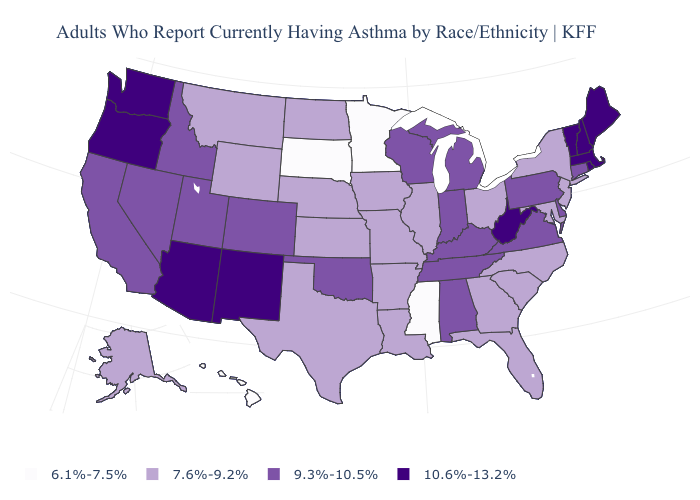Name the states that have a value in the range 7.6%-9.2%?
Write a very short answer. Alaska, Arkansas, Florida, Georgia, Illinois, Iowa, Kansas, Louisiana, Maryland, Missouri, Montana, Nebraska, New Jersey, New York, North Carolina, North Dakota, Ohio, South Carolina, Texas, Wyoming. How many symbols are there in the legend?
Quick response, please. 4. Among the states that border Arkansas , does Mississippi have the lowest value?
Concise answer only. Yes. Name the states that have a value in the range 9.3%-10.5%?
Write a very short answer. Alabama, California, Colorado, Connecticut, Delaware, Idaho, Indiana, Kentucky, Michigan, Nevada, Oklahoma, Pennsylvania, Tennessee, Utah, Virginia, Wisconsin. Does Maine have the highest value in the USA?
Keep it brief. Yes. Which states have the lowest value in the Northeast?
Concise answer only. New Jersey, New York. What is the lowest value in the USA?
Short answer required. 6.1%-7.5%. How many symbols are there in the legend?
Answer briefly. 4. Which states have the lowest value in the USA?
Keep it brief. Hawaii, Minnesota, Mississippi, South Dakota. What is the highest value in states that border North Carolina?
Be succinct. 9.3%-10.5%. Does Rhode Island have a higher value than Colorado?
Short answer required. Yes. What is the highest value in the MidWest ?
Answer briefly. 9.3%-10.5%. What is the lowest value in states that border Iowa?
Short answer required. 6.1%-7.5%. Name the states that have a value in the range 9.3%-10.5%?
Quick response, please. Alabama, California, Colorado, Connecticut, Delaware, Idaho, Indiana, Kentucky, Michigan, Nevada, Oklahoma, Pennsylvania, Tennessee, Utah, Virginia, Wisconsin. Which states have the lowest value in the West?
Concise answer only. Hawaii. 